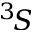<formula> <loc_0><loc_0><loc_500><loc_500>^ { 3 } \, S</formula> 